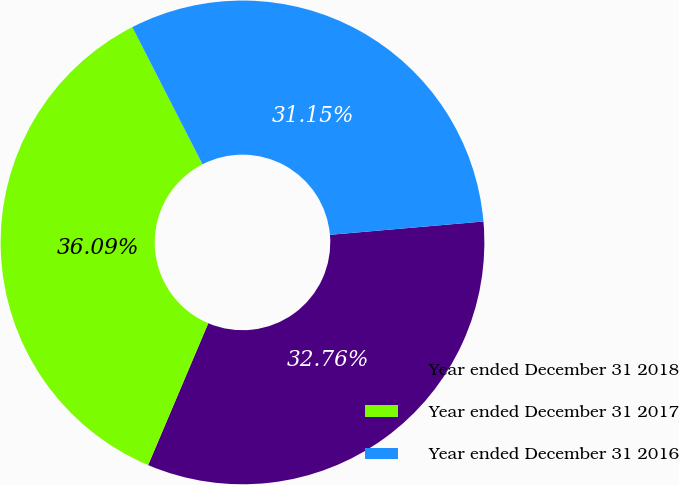Convert chart. <chart><loc_0><loc_0><loc_500><loc_500><pie_chart><fcel>Year ended December 31 2018<fcel>Year ended December 31 2017<fcel>Year ended December 31 2016<nl><fcel>32.76%<fcel>36.09%<fcel>31.15%<nl></chart> 